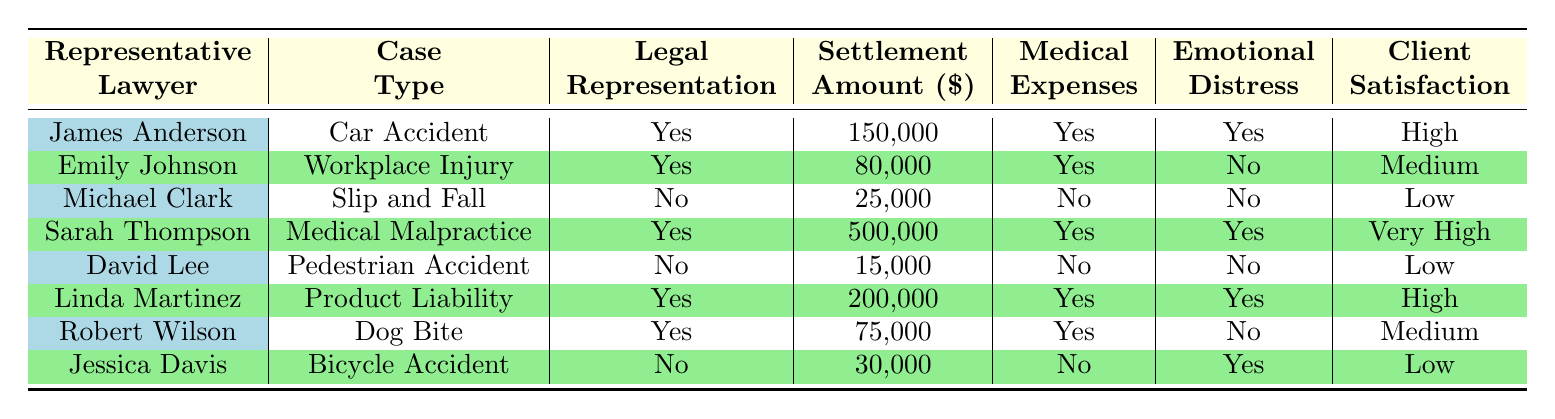What is the highest settlement amount listed in the table? The highest settlement amount can be located by scanning the "Settlement Amount" column. The amounts are 150000, 80000, 25000, 500000, 15000, 200000, 75000, and 30000. The highest among these is 500000.
Answer: 500000 How many cases listed had legal representation? To find this number, look at the "Legal Representation" column and count the entries with "Yes." There are four cases that have "Yes" under this column.
Answer: 4 Which lawyer represented the case with the lowest settlement amount? First, identify the case with the lowest settlement amount by reviewing the "Settlement Amount" column. The lowest amount is 15000 from David Lee for the "Pedestrian Accident" case. Thus, the representative is David Lee.
Answer: David Lee What is the average settlement amount for cases with legal representation? To calculate the average, sum the settlement amounts for cases with legal representation, which are 150000, 80000, 500000, 200000, and 75000. The total is 150000 + 80000 + 500000 + 200000 + 75000 = 1000000. Then divide this sum by the number of cases with legal representation, which is 4: 1000000 / 4 = 250000.
Answer: 250000 Is there any case where emotional distress damages were covered but legal representation was not? Search the "Legal Representation" column for "No" while checking the corresponding "Emotional Distress Damages" column. The cases where legal representation was "No" are Michael Clark and Jessica Davis, but only Michael's case has "No" for emotional distress. Therefore, the answer is no.
Answer: No How many different types of cases had a settlement amount exceeding 100000? Review the "Settlement Amount" column for values greater than 100000. The cases that exceed this amount are Car Accident (150000), Medical Malpractice (500000), and Product Liability (200000). That's three different types of cases.
Answer: 3 Was client satisfaction high for any cases with no legal representation? Examine the "Client Satisfaction" column for cases where "Legal Representation" is "No." The cases with no representation are those of Michael Clark and David Lee, whose satisfaction is listed as Low. Thus, no case with no legal representation has high satisfaction.
Answer: No Who had the highest client satisfaction among lawyers with legal representation? Look at the "Client Satisfaction" column for only those with "Yes" in the "Legal Representation" column. The values are High, Medium, and Very High, with "Very High" being the best recorded level of satisfaction by Sarah Thompson.
Answer: Sarah Thompson 